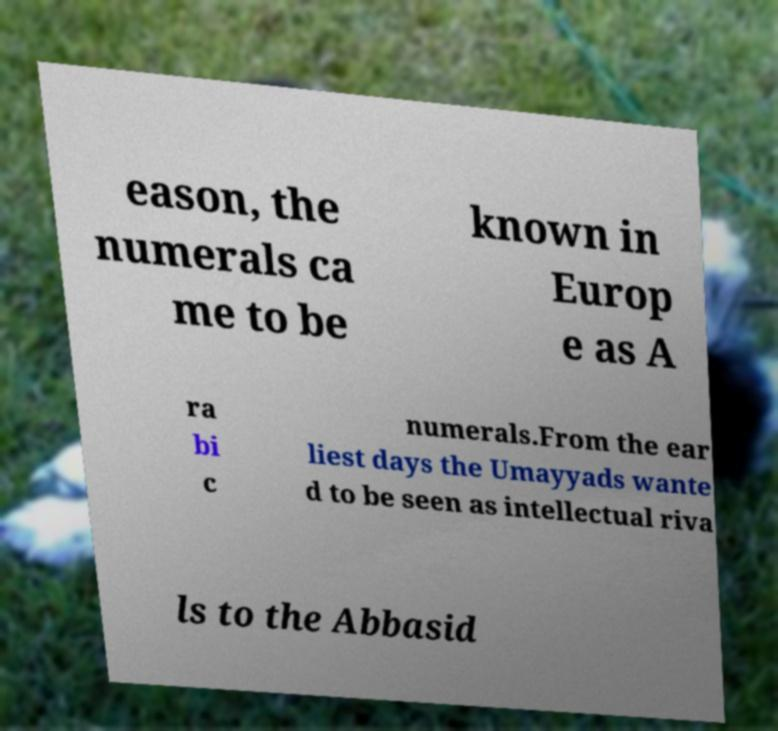I need the written content from this picture converted into text. Can you do that? eason, the numerals ca me to be known in Europ e as A ra bi c numerals.From the ear liest days the Umayyads wante d to be seen as intellectual riva ls to the Abbasid 